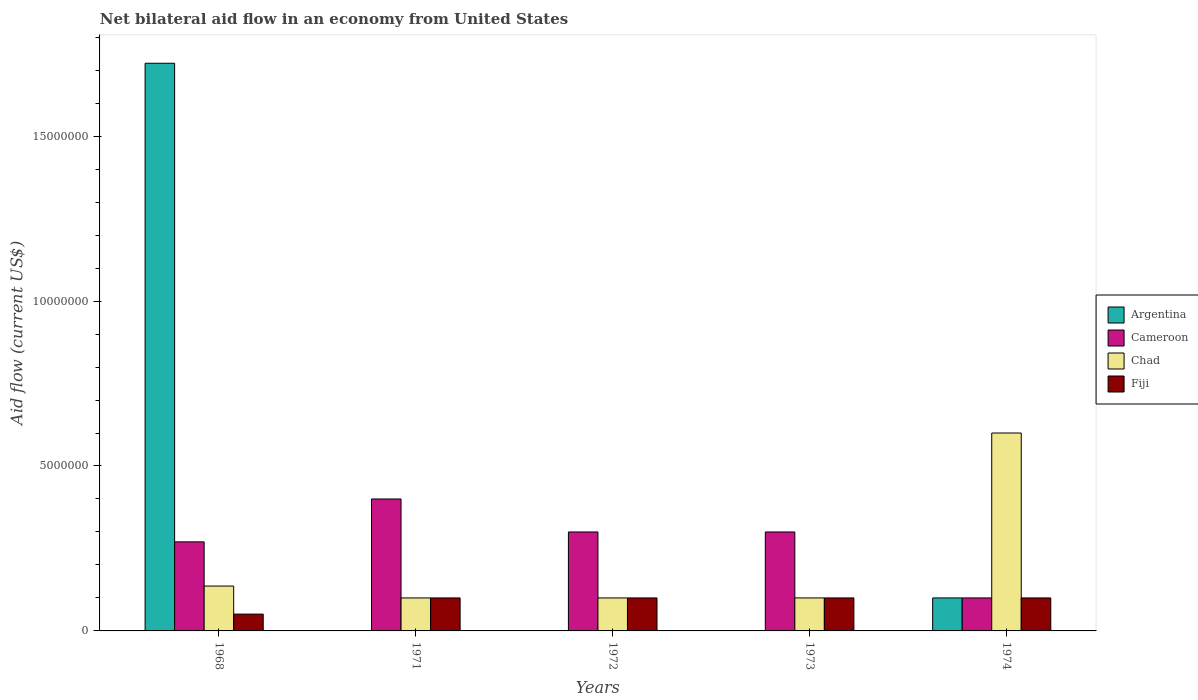Across all years, what is the maximum net bilateral aid flow in Fiji?
Keep it short and to the point. 1.00e+06. Across all years, what is the minimum net bilateral aid flow in Fiji?
Ensure brevity in your answer.  5.10e+05. What is the total net bilateral aid flow in Chad in the graph?
Your answer should be very brief. 1.04e+07. What is the difference between the net bilateral aid flow in Fiji in 1972 and that in 1974?
Provide a succinct answer. 0. What is the difference between the net bilateral aid flow in Cameroon in 1968 and the net bilateral aid flow in Argentina in 1971?
Your answer should be compact. 2.70e+06. What is the average net bilateral aid flow in Argentina per year?
Your answer should be compact. 3.64e+06. In how many years, is the net bilateral aid flow in Cameroon greater than 11000000 US$?
Provide a short and direct response. 0. What is the ratio of the net bilateral aid flow in Chad in 1968 to that in 1971?
Offer a very short reply. 1.36. What is the difference between the highest and the second highest net bilateral aid flow in Chad?
Offer a terse response. 4.64e+06. What is the difference between the highest and the lowest net bilateral aid flow in Fiji?
Your answer should be compact. 4.90e+05. Is the sum of the net bilateral aid flow in Fiji in 1972 and 1973 greater than the maximum net bilateral aid flow in Cameroon across all years?
Provide a succinct answer. No. Is it the case that in every year, the sum of the net bilateral aid flow in Fiji and net bilateral aid flow in Cameroon is greater than the sum of net bilateral aid flow in Argentina and net bilateral aid flow in Chad?
Ensure brevity in your answer.  No. Is it the case that in every year, the sum of the net bilateral aid flow in Argentina and net bilateral aid flow in Cameroon is greater than the net bilateral aid flow in Chad?
Your response must be concise. No. How many bars are there?
Provide a succinct answer. 17. Are all the bars in the graph horizontal?
Provide a succinct answer. No. How many years are there in the graph?
Ensure brevity in your answer.  5. What is the difference between two consecutive major ticks on the Y-axis?
Offer a very short reply. 5.00e+06. Where does the legend appear in the graph?
Keep it short and to the point. Center right. How many legend labels are there?
Offer a terse response. 4. How are the legend labels stacked?
Give a very brief answer. Vertical. What is the title of the graph?
Keep it short and to the point. Net bilateral aid flow in an economy from United States. Does "El Salvador" appear as one of the legend labels in the graph?
Your response must be concise. No. What is the label or title of the X-axis?
Ensure brevity in your answer.  Years. What is the label or title of the Y-axis?
Your answer should be compact. Aid flow (current US$). What is the Aid flow (current US$) in Argentina in 1968?
Make the answer very short. 1.72e+07. What is the Aid flow (current US$) of Cameroon in 1968?
Provide a succinct answer. 2.70e+06. What is the Aid flow (current US$) of Chad in 1968?
Your response must be concise. 1.36e+06. What is the Aid flow (current US$) of Fiji in 1968?
Provide a short and direct response. 5.10e+05. What is the Aid flow (current US$) in Argentina in 1971?
Offer a very short reply. 0. What is the Aid flow (current US$) of Chad in 1971?
Ensure brevity in your answer.  1.00e+06. What is the Aid flow (current US$) in Fiji in 1971?
Provide a succinct answer. 1.00e+06. What is the Aid flow (current US$) in Chad in 1972?
Ensure brevity in your answer.  1.00e+06. What is the Aid flow (current US$) of Fiji in 1972?
Your response must be concise. 1.00e+06. What is the Aid flow (current US$) in Fiji in 1974?
Your answer should be very brief. 1.00e+06. Across all years, what is the maximum Aid flow (current US$) in Argentina?
Provide a short and direct response. 1.72e+07. Across all years, what is the maximum Aid flow (current US$) in Fiji?
Your answer should be compact. 1.00e+06. Across all years, what is the minimum Aid flow (current US$) of Argentina?
Your answer should be very brief. 0. Across all years, what is the minimum Aid flow (current US$) in Cameroon?
Offer a terse response. 1.00e+06. Across all years, what is the minimum Aid flow (current US$) of Fiji?
Provide a short and direct response. 5.10e+05. What is the total Aid flow (current US$) of Argentina in the graph?
Make the answer very short. 1.82e+07. What is the total Aid flow (current US$) in Cameroon in the graph?
Make the answer very short. 1.37e+07. What is the total Aid flow (current US$) in Chad in the graph?
Keep it short and to the point. 1.04e+07. What is the total Aid flow (current US$) of Fiji in the graph?
Keep it short and to the point. 4.51e+06. What is the difference between the Aid flow (current US$) of Cameroon in 1968 and that in 1971?
Ensure brevity in your answer.  -1.30e+06. What is the difference between the Aid flow (current US$) in Chad in 1968 and that in 1971?
Make the answer very short. 3.60e+05. What is the difference between the Aid flow (current US$) in Fiji in 1968 and that in 1971?
Provide a succinct answer. -4.90e+05. What is the difference between the Aid flow (current US$) in Chad in 1968 and that in 1972?
Provide a succinct answer. 3.60e+05. What is the difference between the Aid flow (current US$) of Fiji in 1968 and that in 1972?
Give a very brief answer. -4.90e+05. What is the difference between the Aid flow (current US$) of Cameroon in 1968 and that in 1973?
Offer a very short reply. -3.00e+05. What is the difference between the Aid flow (current US$) in Fiji in 1968 and that in 1973?
Your answer should be compact. -4.90e+05. What is the difference between the Aid flow (current US$) of Argentina in 1968 and that in 1974?
Offer a terse response. 1.62e+07. What is the difference between the Aid flow (current US$) of Cameroon in 1968 and that in 1974?
Ensure brevity in your answer.  1.70e+06. What is the difference between the Aid flow (current US$) in Chad in 1968 and that in 1974?
Your answer should be very brief. -4.64e+06. What is the difference between the Aid flow (current US$) of Fiji in 1968 and that in 1974?
Offer a very short reply. -4.90e+05. What is the difference between the Aid flow (current US$) of Chad in 1971 and that in 1972?
Your answer should be very brief. 0. What is the difference between the Aid flow (current US$) of Fiji in 1971 and that in 1972?
Keep it short and to the point. 0. What is the difference between the Aid flow (current US$) in Chad in 1971 and that in 1973?
Offer a terse response. 0. What is the difference between the Aid flow (current US$) in Fiji in 1971 and that in 1973?
Keep it short and to the point. 0. What is the difference between the Aid flow (current US$) in Cameroon in 1971 and that in 1974?
Ensure brevity in your answer.  3.00e+06. What is the difference between the Aid flow (current US$) in Chad in 1971 and that in 1974?
Your answer should be very brief. -5.00e+06. What is the difference between the Aid flow (current US$) in Fiji in 1972 and that in 1973?
Provide a short and direct response. 0. What is the difference between the Aid flow (current US$) of Chad in 1972 and that in 1974?
Your response must be concise. -5.00e+06. What is the difference between the Aid flow (current US$) of Fiji in 1972 and that in 1974?
Offer a very short reply. 0. What is the difference between the Aid flow (current US$) of Chad in 1973 and that in 1974?
Offer a very short reply. -5.00e+06. What is the difference between the Aid flow (current US$) in Argentina in 1968 and the Aid flow (current US$) in Cameroon in 1971?
Your answer should be very brief. 1.32e+07. What is the difference between the Aid flow (current US$) of Argentina in 1968 and the Aid flow (current US$) of Chad in 1971?
Provide a short and direct response. 1.62e+07. What is the difference between the Aid flow (current US$) in Argentina in 1968 and the Aid flow (current US$) in Fiji in 1971?
Your answer should be very brief. 1.62e+07. What is the difference between the Aid flow (current US$) of Cameroon in 1968 and the Aid flow (current US$) of Chad in 1971?
Your answer should be compact. 1.70e+06. What is the difference between the Aid flow (current US$) in Cameroon in 1968 and the Aid flow (current US$) in Fiji in 1971?
Give a very brief answer. 1.70e+06. What is the difference between the Aid flow (current US$) of Chad in 1968 and the Aid flow (current US$) of Fiji in 1971?
Your answer should be compact. 3.60e+05. What is the difference between the Aid flow (current US$) of Argentina in 1968 and the Aid flow (current US$) of Cameroon in 1972?
Make the answer very short. 1.42e+07. What is the difference between the Aid flow (current US$) of Argentina in 1968 and the Aid flow (current US$) of Chad in 1972?
Make the answer very short. 1.62e+07. What is the difference between the Aid flow (current US$) of Argentina in 1968 and the Aid flow (current US$) of Fiji in 1972?
Your response must be concise. 1.62e+07. What is the difference between the Aid flow (current US$) in Cameroon in 1968 and the Aid flow (current US$) in Chad in 1972?
Give a very brief answer. 1.70e+06. What is the difference between the Aid flow (current US$) of Cameroon in 1968 and the Aid flow (current US$) of Fiji in 1972?
Give a very brief answer. 1.70e+06. What is the difference between the Aid flow (current US$) of Chad in 1968 and the Aid flow (current US$) of Fiji in 1972?
Make the answer very short. 3.60e+05. What is the difference between the Aid flow (current US$) in Argentina in 1968 and the Aid flow (current US$) in Cameroon in 1973?
Provide a succinct answer. 1.42e+07. What is the difference between the Aid flow (current US$) in Argentina in 1968 and the Aid flow (current US$) in Chad in 1973?
Make the answer very short. 1.62e+07. What is the difference between the Aid flow (current US$) of Argentina in 1968 and the Aid flow (current US$) of Fiji in 1973?
Make the answer very short. 1.62e+07. What is the difference between the Aid flow (current US$) of Cameroon in 1968 and the Aid flow (current US$) of Chad in 1973?
Your response must be concise. 1.70e+06. What is the difference between the Aid flow (current US$) in Cameroon in 1968 and the Aid flow (current US$) in Fiji in 1973?
Offer a very short reply. 1.70e+06. What is the difference between the Aid flow (current US$) in Chad in 1968 and the Aid flow (current US$) in Fiji in 1973?
Provide a short and direct response. 3.60e+05. What is the difference between the Aid flow (current US$) in Argentina in 1968 and the Aid flow (current US$) in Cameroon in 1974?
Give a very brief answer. 1.62e+07. What is the difference between the Aid flow (current US$) of Argentina in 1968 and the Aid flow (current US$) of Chad in 1974?
Offer a very short reply. 1.12e+07. What is the difference between the Aid flow (current US$) in Argentina in 1968 and the Aid flow (current US$) in Fiji in 1974?
Provide a short and direct response. 1.62e+07. What is the difference between the Aid flow (current US$) of Cameroon in 1968 and the Aid flow (current US$) of Chad in 1974?
Your answer should be compact. -3.30e+06. What is the difference between the Aid flow (current US$) in Cameroon in 1968 and the Aid flow (current US$) in Fiji in 1974?
Offer a terse response. 1.70e+06. What is the difference between the Aid flow (current US$) of Chad in 1968 and the Aid flow (current US$) of Fiji in 1974?
Offer a terse response. 3.60e+05. What is the difference between the Aid flow (current US$) in Chad in 1971 and the Aid flow (current US$) in Fiji in 1972?
Keep it short and to the point. 0. What is the difference between the Aid flow (current US$) of Cameroon in 1971 and the Aid flow (current US$) of Chad in 1974?
Offer a very short reply. -2.00e+06. What is the difference between the Aid flow (current US$) of Chad in 1971 and the Aid flow (current US$) of Fiji in 1974?
Make the answer very short. 0. What is the difference between the Aid flow (current US$) in Cameroon in 1972 and the Aid flow (current US$) in Chad in 1974?
Keep it short and to the point. -3.00e+06. What is the difference between the Aid flow (current US$) of Chad in 1972 and the Aid flow (current US$) of Fiji in 1974?
Make the answer very short. 0. What is the difference between the Aid flow (current US$) in Cameroon in 1973 and the Aid flow (current US$) in Chad in 1974?
Offer a very short reply. -3.00e+06. What is the difference between the Aid flow (current US$) of Cameroon in 1973 and the Aid flow (current US$) of Fiji in 1974?
Your response must be concise. 2.00e+06. What is the average Aid flow (current US$) in Argentina per year?
Ensure brevity in your answer.  3.64e+06. What is the average Aid flow (current US$) in Cameroon per year?
Your answer should be very brief. 2.74e+06. What is the average Aid flow (current US$) of Chad per year?
Your answer should be compact. 2.07e+06. What is the average Aid flow (current US$) of Fiji per year?
Make the answer very short. 9.02e+05. In the year 1968, what is the difference between the Aid flow (current US$) of Argentina and Aid flow (current US$) of Cameroon?
Your answer should be very brief. 1.45e+07. In the year 1968, what is the difference between the Aid flow (current US$) in Argentina and Aid flow (current US$) in Chad?
Your response must be concise. 1.58e+07. In the year 1968, what is the difference between the Aid flow (current US$) of Argentina and Aid flow (current US$) of Fiji?
Offer a very short reply. 1.67e+07. In the year 1968, what is the difference between the Aid flow (current US$) in Cameroon and Aid flow (current US$) in Chad?
Offer a very short reply. 1.34e+06. In the year 1968, what is the difference between the Aid flow (current US$) in Cameroon and Aid flow (current US$) in Fiji?
Give a very brief answer. 2.19e+06. In the year 1968, what is the difference between the Aid flow (current US$) in Chad and Aid flow (current US$) in Fiji?
Give a very brief answer. 8.50e+05. In the year 1971, what is the difference between the Aid flow (current US$) of Cameroon and Aid flow (current US$) of Chad?
Give a very brief answer. 3.00e+06. In the year 1972, what is the difference between the Aid flow (current US$) in Cameroon and Aid flow (current US$) in Chad?
Offer a very short reply. 2.00e+06. In the year 1972, what is the difference between the Aid flow (current US$) of Cameroon and Aid flow (current US$) of Fiji?
Your response must be concise. 2.00e+06. In the year 1972, what is the difference between the Aid flow (current US$) in Chad and Aid flow (current US$) in Fiji?
Your answer should be very brief. 0. In the year 1973, what is the difference between the Aid flow (current US$) in Cameroon and Aid flow (current US$) in Chad?
Make the answer very short. 2.00e+06. In the year 1973, what is the difference between the Aid flow (current US$) of Cameroon and Aid flow (current US$) of Fiji?
Your answer should be very brief. 2.00e+06. In the year 1973, what is the difference between the Aid flow (current US$) of Chad and Aid flow (current US$) of Fiji?
Provide a succinct answer. 0. In the year 1974, what is the difference between the Aid flow (current US$) of Argentina and Aid flow (current US$) of Chad?
Offer a very short reply. -5.00e+06. In the year 1974, what is the difference between the Aid flow (current US$) of Argentina and Aid flow (current US$) of Fiji?
Keep it short and to the point. 0. In the year 1974, what is the difference between the Aid flow (current US$) in Cameroon and Aid flow (current US$) in Chad?
Your answer should be very brief. -5.00e+06. In the year 1974, what is the difference between the Aid flow (current US$) in Cameroon and Aid flow (current US$) in Fiji?
Keep it short and to the point. 0. In the year 1974, what is the difference between the Aid flow (current US$) of Chad and Aid flow (current US$) of Fiji?
Your response must be concise. 5.00e+06. What is the ratio of the Aid flow (current US$) of Cameroon in 1968 to that in 1971?
Make the answer very short. 0.68. What is the ratio of the Aid flow (current US$) in Chad in 1968 to that in 1971?
Your answer should be very brief. 1.36. What is the ratio of the Aid flow (current US$) of Fiji in 1968 to that in 1971?
Offer a very short reply. 0.51. What is the ratio of the Aid flow (current US$) in Chad in 1968 to that in 1972?
Give a very brief answer. 1.36. What is the ratio of the Aid flow (current US$) in Fiji in 1968 to that in 1972?
Keep it short and to the point. 0.51. What is the ratio of the Aid flow (current US$) in Cameroon in 1968 to that in 1973?
Provide a succinct answer. 0.9. What is the ratio of the Aid flow (current US$) of Chad in 1968 to that in 1973?
Your answer should be very brief. 1.36. What is the ratio of the Aid flow (current US$) of Fiji in 1968 to that in 1973?
Your answer should be compact. 0.51. What is the ratio of the Aid flow (current US$) in Argentina in 1968 to that in 1974?
Your answer should be compact. 17.21. What is the ratio of the Aid flow (current US$) in Chad in 1968 to that in 1974?
Your response must be concise. 0.23. What is the ratio of the Aid flow (current US$) in Fiji in 1968 to that in 1974?
Make the answer very short. 0.51. What is the ratio of the Aid flow (current US$) in Cameroon in 1971 to that in 1972?
Offer a very short reply. 1.33. What is the ratio of the Aid flow (current US$) of Cameroon in 1971 to that in 1973?
Ensure brevity in your answer.  1.33. What is the ratio of the Aid flow (current US$) in Chad in 1971 to that in 1973?
Your answer should be compact. 1. What is the ratio of the Aid flow (current US$) of Fiji in 1971 to that in 1973?
Your answer should be very brief. 1. What is the ratio of the Aid flow (current US$) of Cameroon in 1971 to that in 1974?
Ensure brevity in your answer.  4. What is the ratio of the Aid flow (current US$) in Fiji in 1971 to that in 1974?
Keep it short and to the point. 1. What is the ratio of the Aid flow (current US$) in Chad in 1972 to that in 1973?
Your answer should be very brief. 1. What is the ratio of the Aid flow (current US$) of Chad in 1972 to that in 1974?
Ensure brevity in your answer.  0.17. What is the difference between the highest and the second highest Aid flow (current US$) of Cameroon?
Offer a very short reply. 1.00e+06. What is the difference between the highest and the second highest Aid flow (current US$) of Chad?
Give a very brief answer. 4.64e+06. What is the difference between the highest and the second highest Aid flow (current US$) in Fiji?
Your answer should be very brief. 0. What is the difference between the highest and the lowest Aid flow (current US$) in Argentina?
Offer a very short reply. 1.72e+07. What is the difference between the highest and the lowest Aid flow (current US$) in Chad?
Offer a terse response. 5.00e+06. What is the difference between the highest and the lowest Aid flow (current US$) in Fiji?
Make the answer very short. 4.90e+05. 